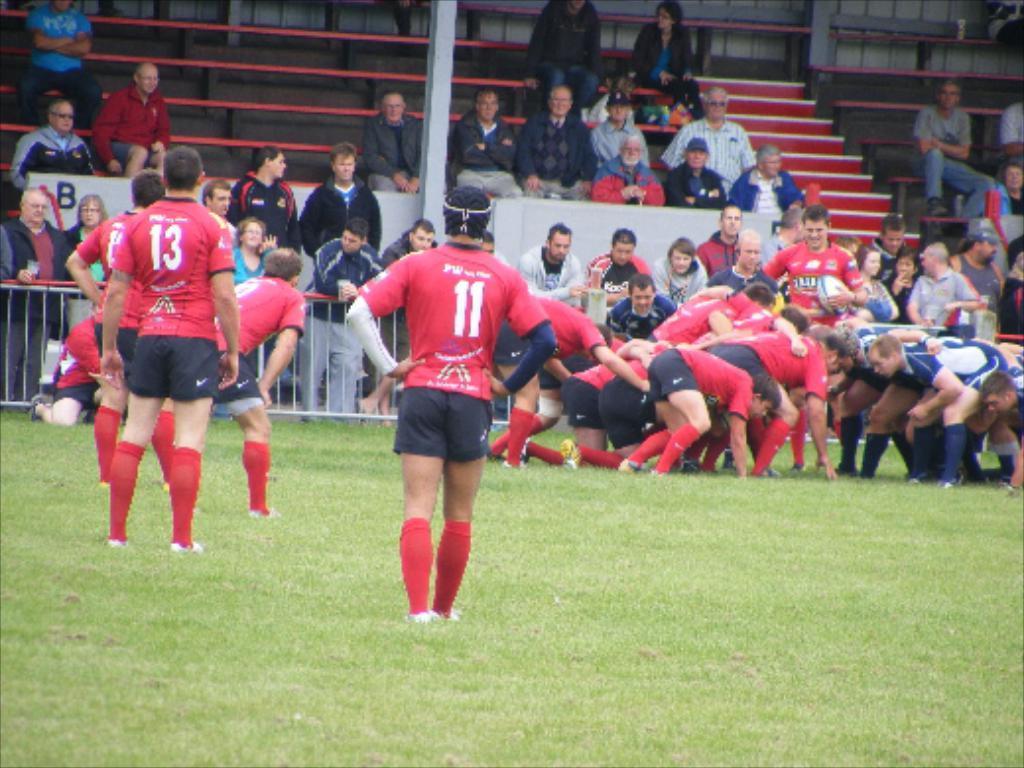Can you describe this image briefly? In this picture I can observe some people playing rugby. There are red and blue color jerseys. I can observe some grass on the ground. There are some people standing behind the railing. Some of them are sitting on the steps and benches. There are men and women in this picture. 